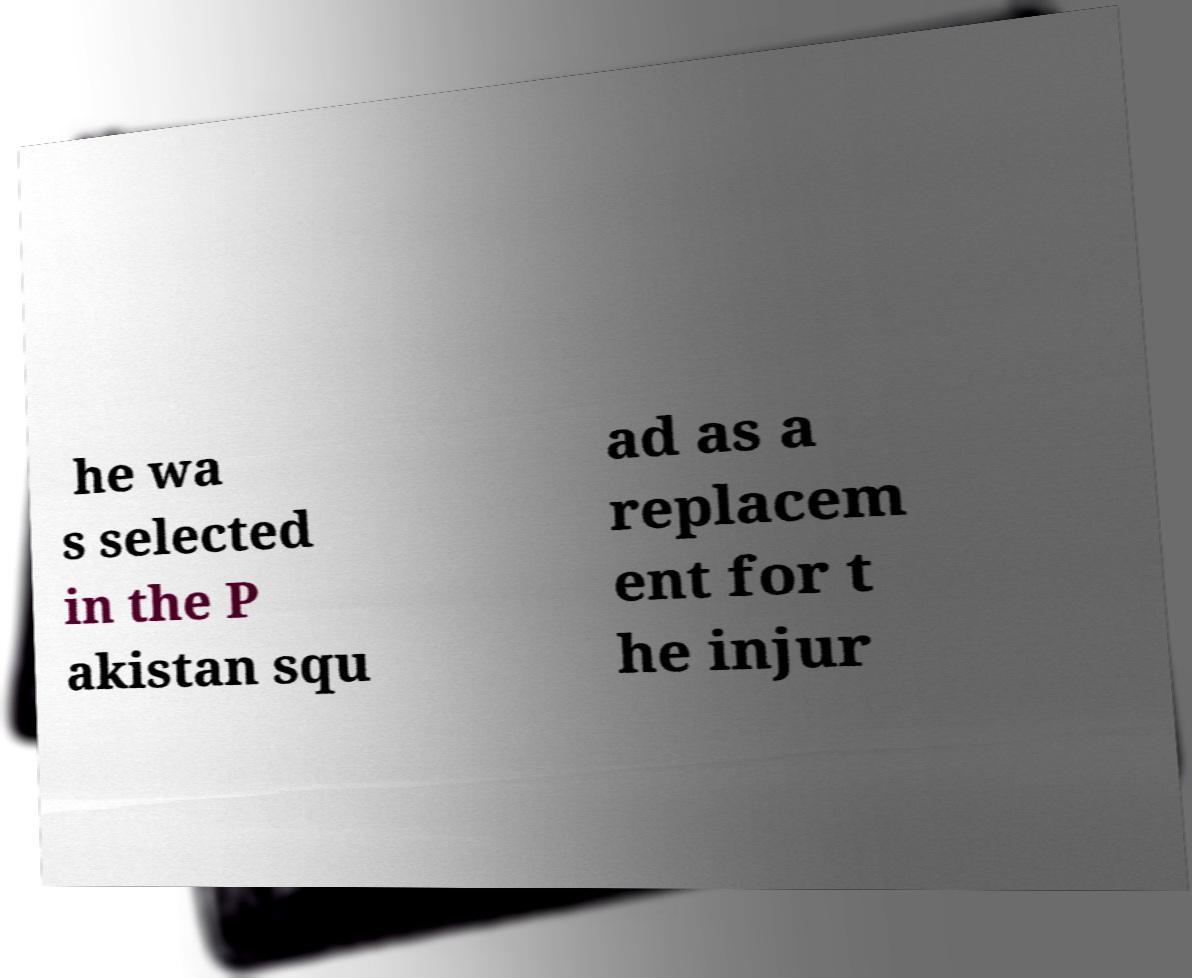Could you assist in decoding the text presented in this image and type it out clearly? he wa s selected in the P akistan squ ad as a replacem ent for t he injur 